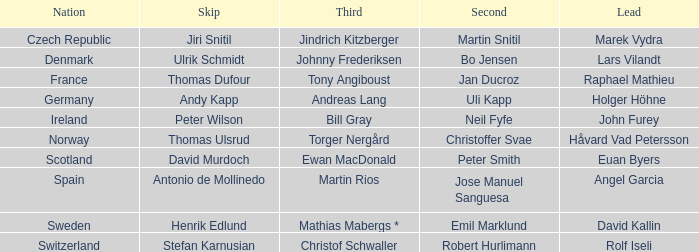Can you give me this table as a dict? {'header': ['Nation', 'Skip', 'Third', 'Second', 'Lead'], 'rows': [['Czech Republic', 'Jiri Snitil', 'Jindrich Kitzberger', 'Martin Snitil', 'Marek Vydra'], ['Denmark', 'Ulrik Schmidt', 'Johnny Frederiksen', 'Bo Jensen', 'Lars Vilandt'], ['France', 'Thomas Dufour', 'Tony Angiboust', 'Jan Ducroz', 'Raphael Mathieu'], ['Germany', 'Andy Kapp', 'Andreas Lang', 'Uli Kapp', 'Holger Höhne'], ['Ireland', 'Peter Wilson', 'Bill Gray', 'Neil Fyfe', 'John Furey'], ['Norway', 'Thomas Ulsrud', 'Torger Nergård', 'Christoffer Svae', 'Håvard Vad Petersson'], ['Scotland', 'David Murdoch', 'Ewan MacDonald', 'Peter Smith', 'Euan Byers'], ['Spain', 'Antonio de Mollinedo', 'Martin Rios', 'Jose Manuel Sanguesa', 'Angel Garcia'], ['Sweden', 'Henrik Edlund', 'Mathias Mabergs *', 'Emil Marklund', 'David Kallin'], ['Switzerland', 'Stefan Karnusian', 'Christof Schwaller', 'Robert Hurlimann', 'Rolf Iseli']]} When did holger höhne come in third? Andreas Lang. 